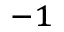<formula> <loc_0><loc_0><loc_500><loc_500>^ { - 1 }</formula> 